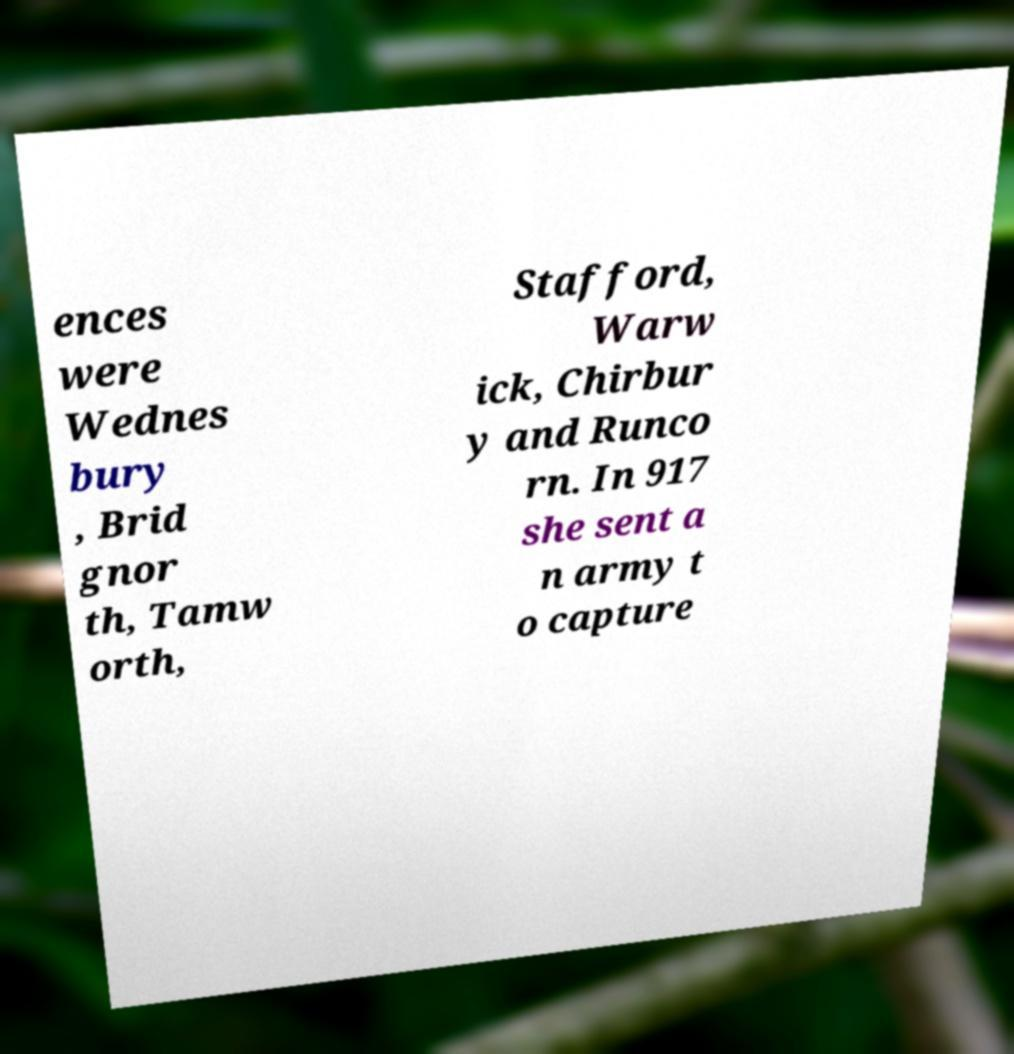Can you accurately transcribe the text from the provided image for me? ences were Wednes bury , Brid gnor th, Tamw orth, Stafford, Warw ick, Chirbur y and Runco rn. In 917 she sent a n army t o capture 